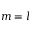<formula> <loc_0><loc_0><loc_500><loc_500>m = l</formula> 